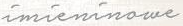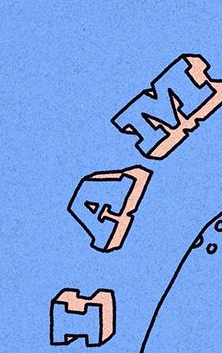Read the text content from these images in order, separated by a semicolon. imieninowe; IAM 